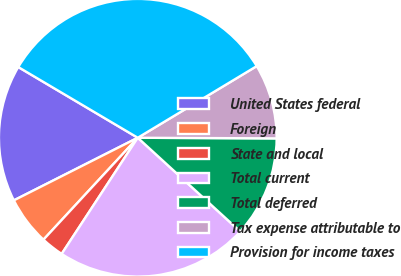<chart> <loc_0><loc_0><loc_500><loc_500><pie_chart><fcel>United States federal<fcel>Foreign<fcel>State and local<fcel>Total current<fcel>Total deferred<fcel>Tax expense attributable to<fcel>Provision for income taxes<nl><fcel>15.95%<fcel>5.67%<fcel>2.65%<fcel>22.44%<fcel>11.72%<fcel>8.7%<fcel>32.87%<nl></chart> 